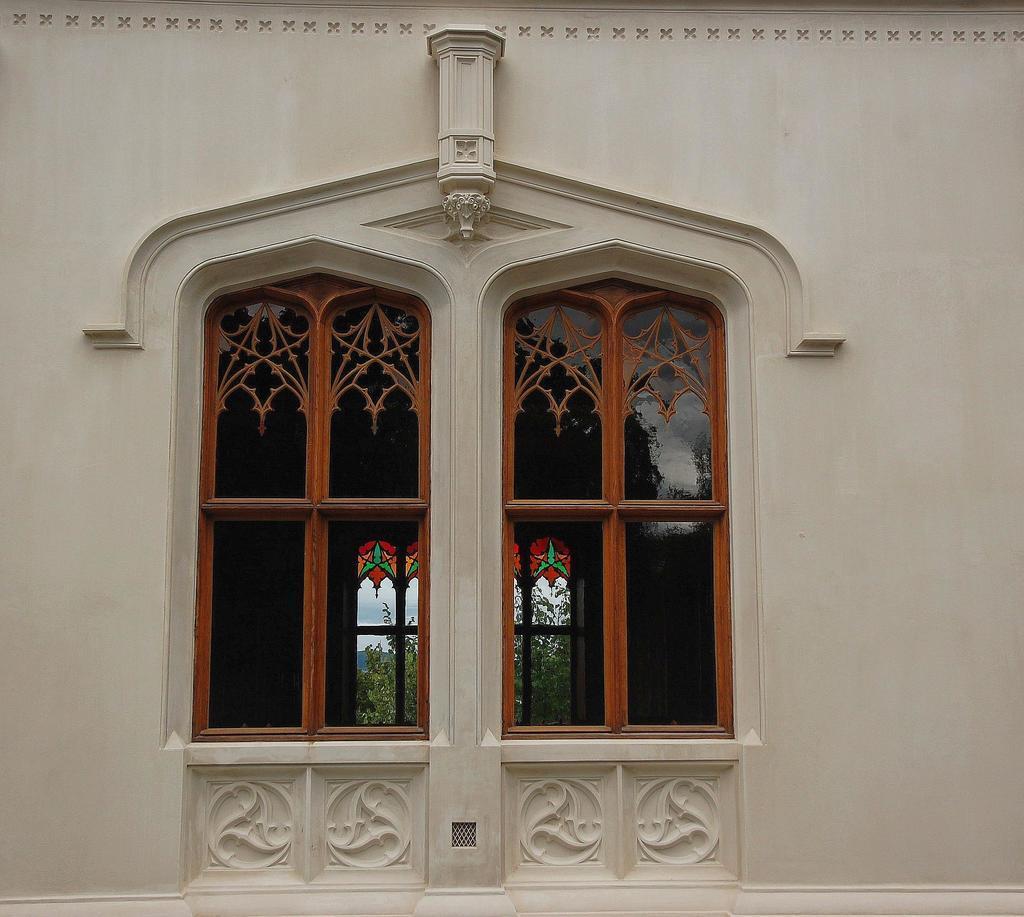Can you describe this image briefly? In this image we can see the wall, glass windows through which we can see trees and sky in the background. 